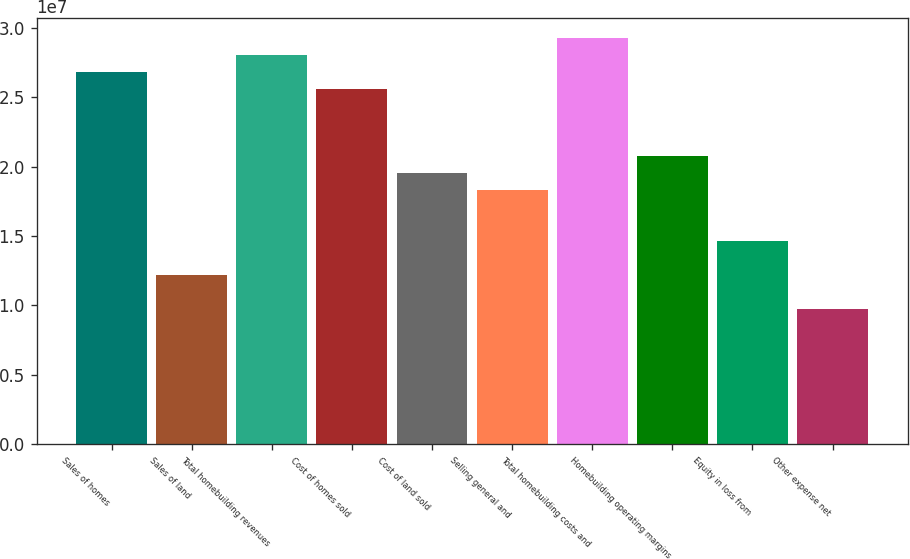Convert chart. <chart><loc_0><loc_0><loc_500><loc_500><bar_chart><fcel>Sales of homes<fcel>Sales of land<fcel>Total homebuilding revenues<fcel>Cost of homes sold<fcel>Cost of land sold<fcel>Selling general and<fcel>Total homebuilding costs and<fcel>Homebuilding operating margins<fcel>Equity in loss from<fcel>Other expense net<nl><fcel>2.6816e+07<fcel>1.21891e+07<fcel>2.80349e+07<fcel>2.55971e+07<fcel>1.95025e+07<fcel>1.82836e+07<fcel>2.92538e+07<fcel>2.07214e+07<fcel>1.46269e+07<fcel>9.75126e+06<nl></chart> 